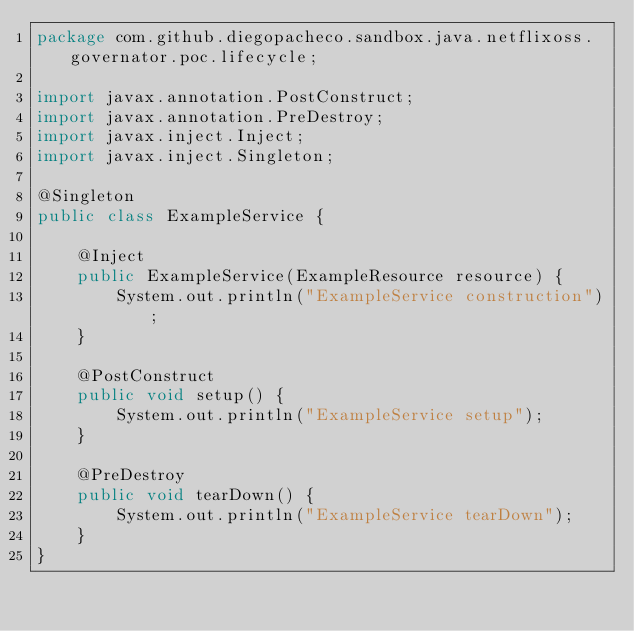<code> <loc_0><loc_0><loc_500><loc_500><_Java_>package com.github.diegopacheco.sandbox.java.netflixoss.governator.poc.lifecycle;

import javax.annotation.PostConstruct;
import javax.annotation.PreDestroy;
import javax.inject.Inject;
import javax.inject.Singleton;

@Singleton
public class ExampleService {
	
	@Inject
	public ExampleService(ExampleResource resource) {
		System.out.println("ExampleService construction");
	}

	@PostConstruct
	public void setup() {
		System.out.println("ExampleService setup");
	}

	@PreDestroy
	public void tearDown() {
		System.out.println("ExampleService tearDown");
	}
}</code> 